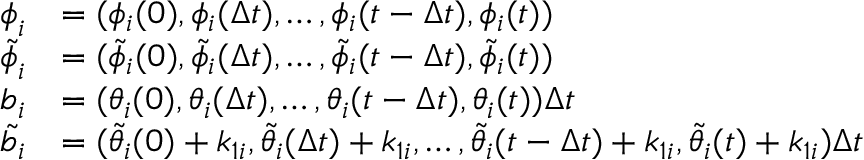<formula> <loc_0><loc_0><loc_500><loc_500>\begin{array} { r l } { \phi _ { i } } & { = ( \phi _ { i } ( 0 ) , \phi _ { i } ( \Delta t ) , \dots , \phi _ { i } ( t - \Delta t ) , \phi _ { i } ( t ) ) } \\ { \tilde { \phi } _ { i } } & { = ( \tilde { \phi } _ { i } ( 0 ) , \tilde { \phi } _ { i } ( \Delta t ) , \dots , \tilde { \phi } _ { i } ( t - \Delta t ) , \tilde { \phi } _ { i } ( t ) ) } \\ { b _ { i } } & { = ( \theta _ { i } ( 0 ) , \theta _ { i } ( \Delta t ) , \dots , \theta _ { i } ( t - \Delta t ) , \theta _ { i } ( t ) ) \Delta t } \\ { \tilde { b } _ { i } } & { = ( \tilde { \theta } _ { i } ( 0 ) + k _ { 1 i } , \tilde { \theta } _ { i } ( \Delta t ) + k _ { 1 i } , \dots , \tilde { \theta } _ { i } ( t - \Delta t ) + k _ { 1 i } , \tilde { \theta } _ { i } ( t ) + k _ { 1 i } ) \Delta t } \end{array}</formula> 